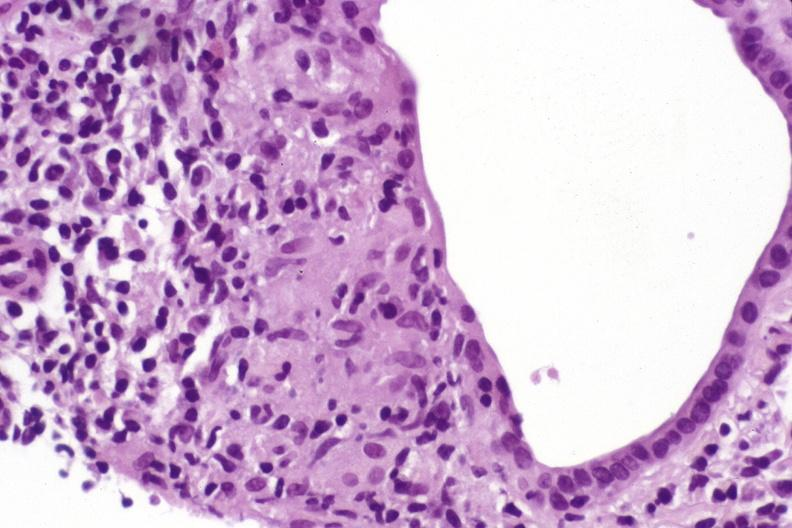s jejunum present?
Answer the question using a single word or phrase. No 